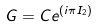<formula> <loc_0><loc_0><loc_500><loc_500>G = C e ^ { ( i \pi I _ { 2 } ) }</formula> 